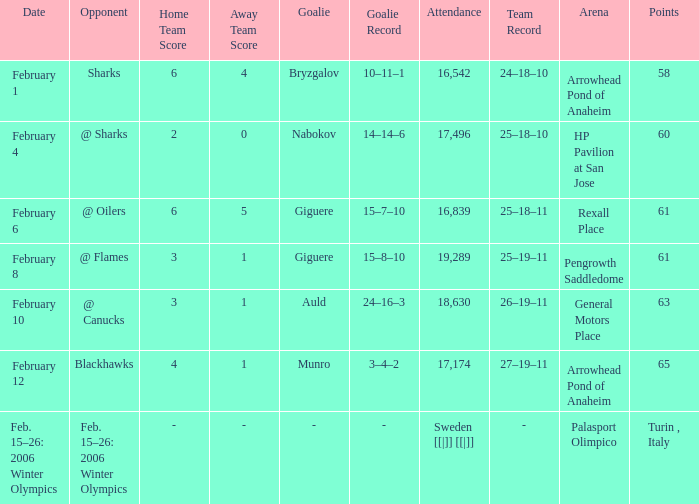What is the points when the score was 3–1, and record was 25–19–11? 61.0. 